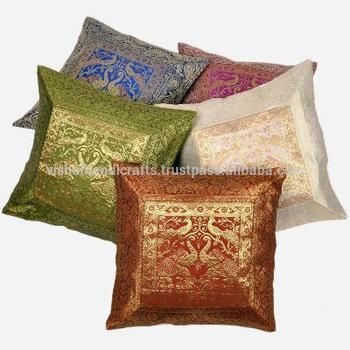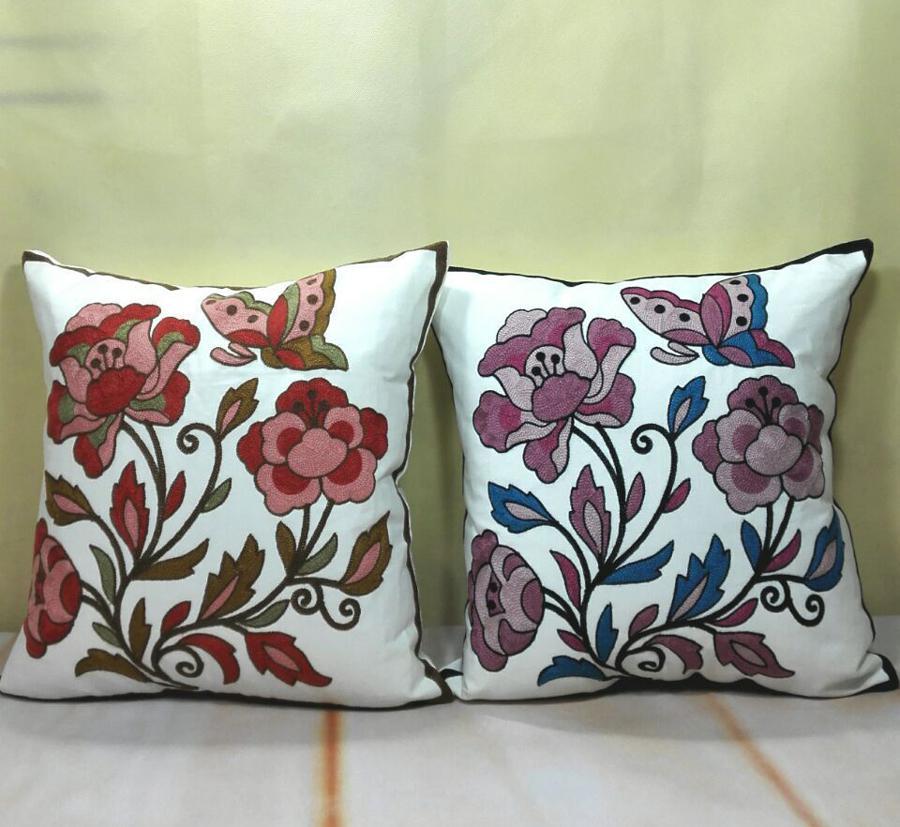The first image is the image on the left, the second image is the image on the right. Examine the images to the left and right. Is the description "there are two throw pillows in the right image" accurate? Answer yes or no. Yes. 